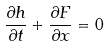Convert formula to latex. <formula><loc_0><loc_0><loc_500><loc_500>\frac { \partial h } { \partial t } + \frac { \partial F } { \partial x } = 0</formula> 